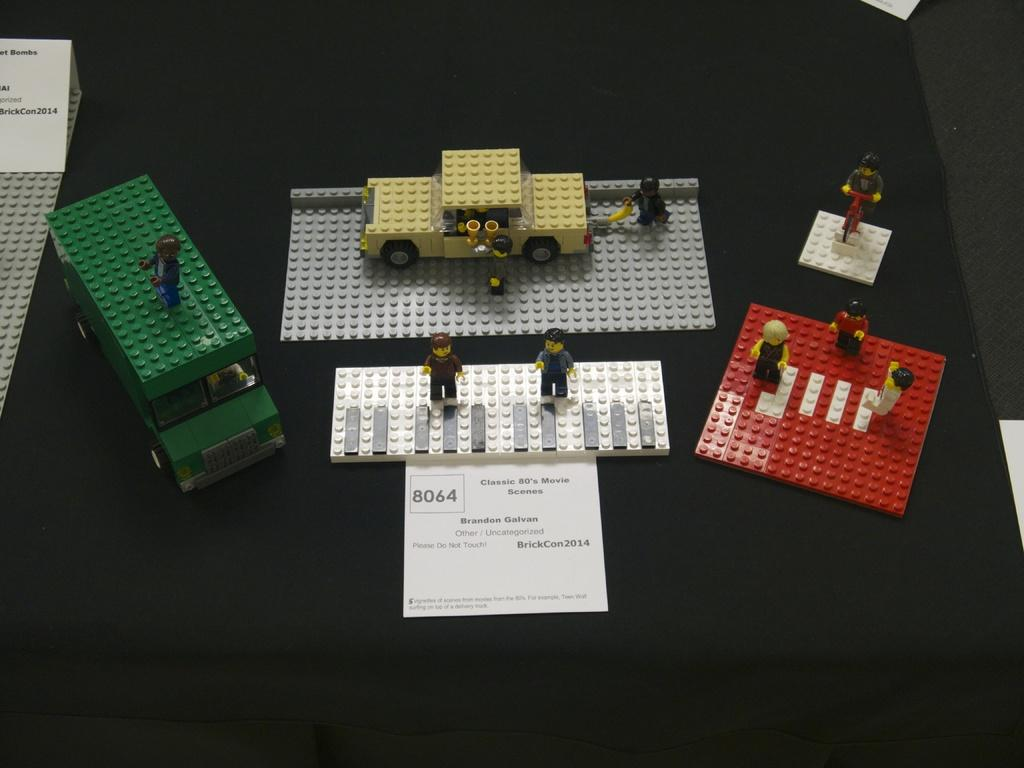What objects can be seen in the image? There are toys and a paper with text on a black surface in the image. Can you describe the paper in the image? The paper has text on it and is placed on a black surface. Where are the toys and the paper with text located in the image? The toys and the paper with text are on the left side of the image. How many servants are present in the image? There are no servants present in the image. What type of boot can be seen on the right side of the image? There is no boot present in the image. 